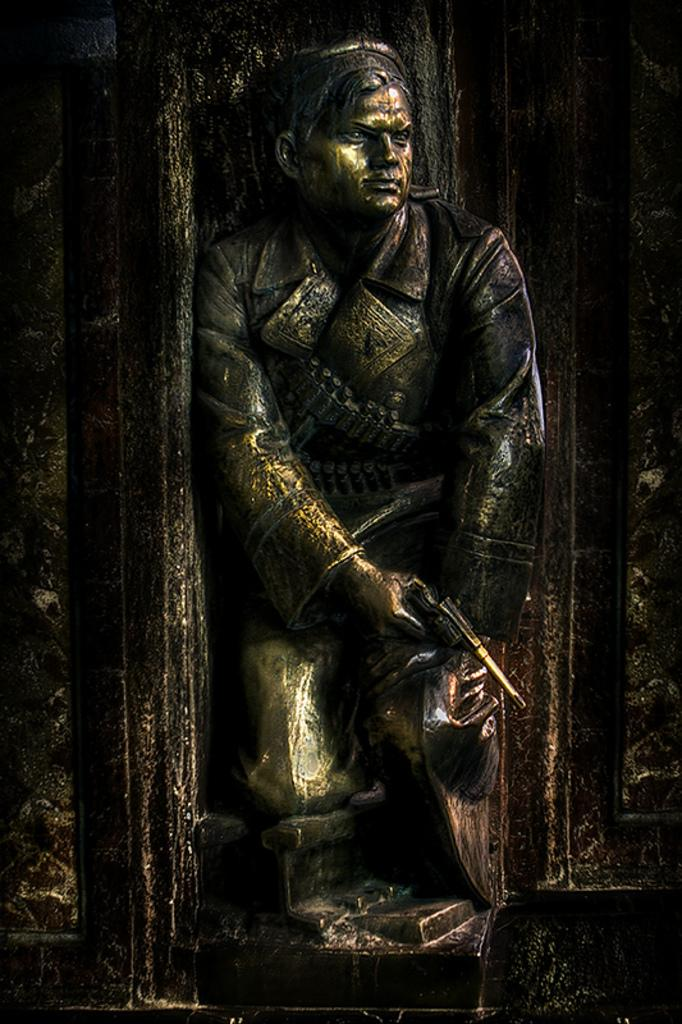What is depicted in the carving in the image? There is a carving of a human in the image. What is the human holding in the carving? The human is holding a gun in the carving. What can be seen in the background of the image? There is a wall in the background of the image. How many dimes are scattered on the floor in the image? There are no dimes present in the image. What type of land is visible in the image? The image does not depict any land; it features a carving of a human holding a gun with a wall in the background. 